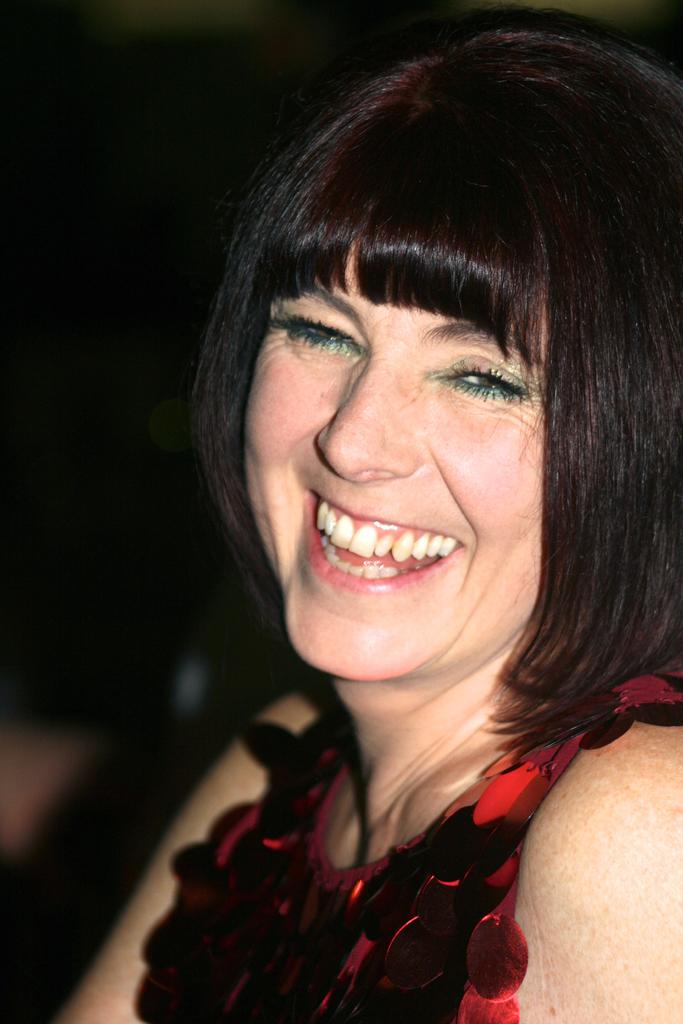Who is present in the image? There is a woman in the image. What is the woman's facial expression? The woman is smiling. Can you describe the background of the image? The background of the image is dark. What type of food is the woman holding in the image? There is no food visible in the image; the woman is not holding any food. 